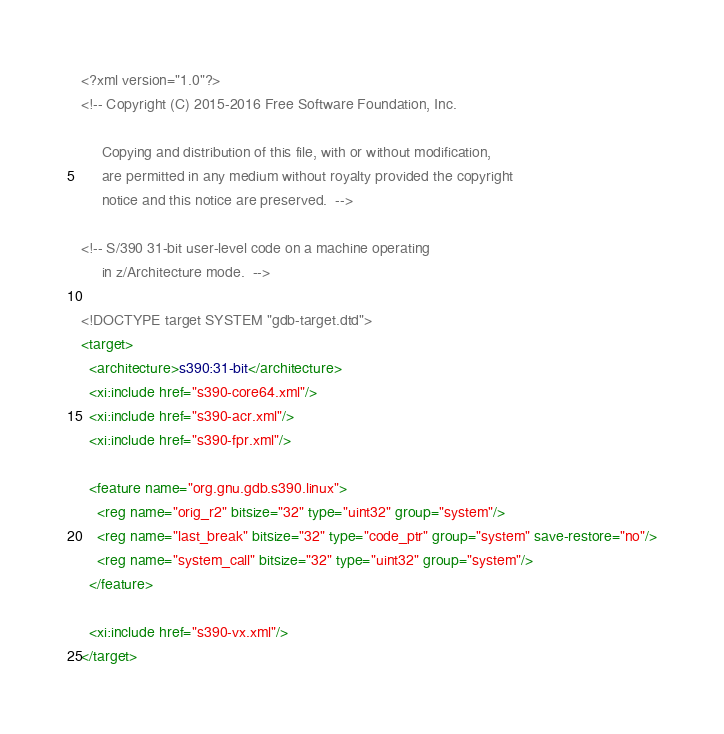<code> <loc_0><loc_0><loc_500><loc_500><_XML_><?xml version="1.0"?>
<!-- Copyright (C) 2015-2016 Free Software Foundation, Inc.

     Copying and distribution of this file, with or without modification,
     are permitted in any medium without royalty provided the copyright
     notice and this notice are preserved.  -->

<!-- S/390 31-bit user-level code on a machine operating
     in z/Architecture mode.  -->

<!DOCTYPE target SYSTEM "gdb-target.dtd">
<target>
  <architecture>s390:31-bit</architecture>
  <xi:include href="s390-core64.xml"/>
  <xi:include href="s390-acr.xml"/>
  <xi:include href="s390-fpr.xml"/>

  <feature name="org.gnu.gdb.s390.linux">
    <reg name="orig_r2" bitsize="32" type="uint32" group="system"/>
    <reg name="last_break" bitsize="32" type="code_ptr" group="system" save-restore="no"/>
    <reg name="system_call" bitsize="32" type="uint32" group="system"/>
  </feature>

  <xi:include href="s390-vx.xml"/>
</target>
</code> 